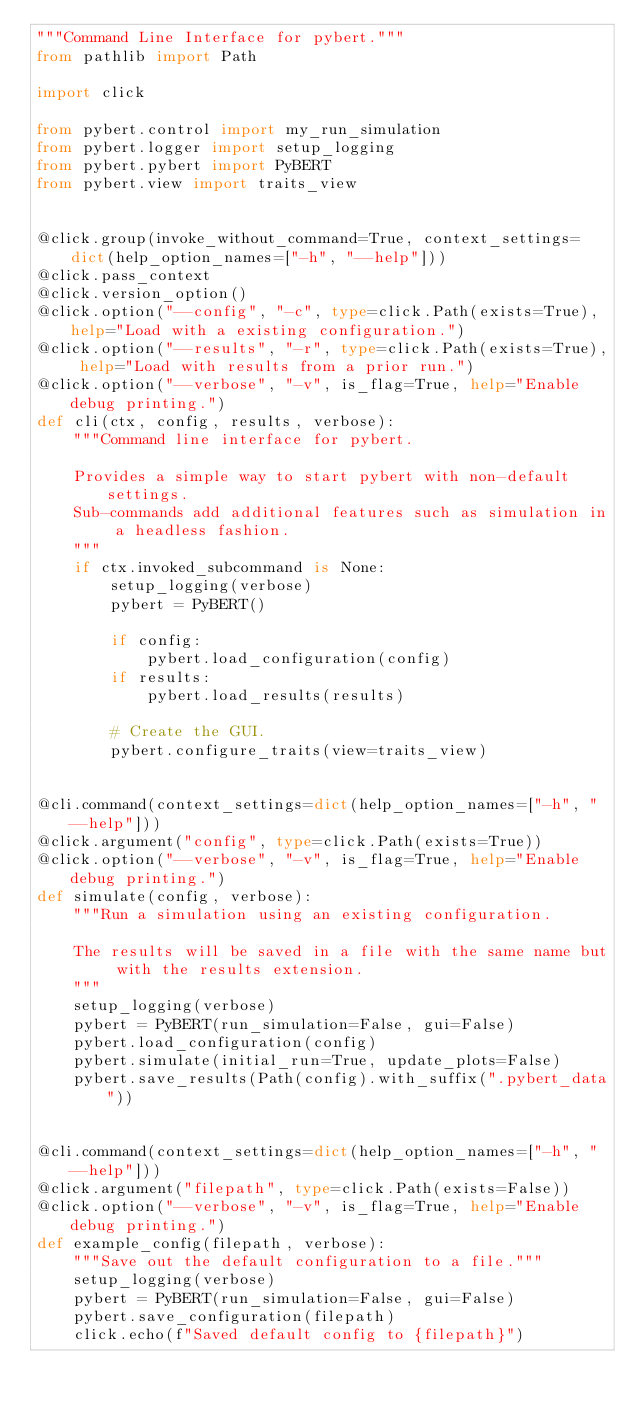Convert code to text. <code><loc_0><loc_0><loc_500><loc_500><_Python_>"""Command Line Interface for pybert."""
from pathlib import Path

import click

from pybert.control import my_run_simulation
from pybert.logger import setup_logging
from pybert.pybert import PyBERT
from pybert.view import traits_view


@click.group(invoke_without_command=True, context_settings=dict(help_option_names=["-h", "--help"]))
@click.pass_context
@click.version_option()
@click.option("--config", "-c", type=click.Path(exists=True), help="Load with a existing configuration.")
@click.option("--results", "-r", type=click.Path(exists=True), help="Load with results from a prior run.")
@click.option("--verbose", "-v", is_flag=True, help="Enable debug printing.")
def cli(ctx, config, results, verbose):
    """Command line interface for pybert.

    Provides a simple way to start pybert with non-default settings.
    Sub-commands add additional features such as simulation in a headless fashion.
    """
    if ctx.invoked_subcommand is None:
        setup_logging(verbose)
        pybert = PyBERT()

        if config:
            pybert.load_configuration(config)
        if results:
            pybert.load_results(results)

        # Create the GUI.
        pybert.configure_traits(view=traits_view)


@cli.command(context_settings=dict(help_option_names=["-h", "--help"]))
@click.argument("config", type=click.Path(exists=True))
@click.option("--verbose", "-v", is_flag=True, help="Enable debug printing.")
def simulate(config, verbose):
    """Run a simulation using an existing configuration.

    The results will be saved in a file with the same name but with the results extension.
    """
    setup_logging(verbose)
    pybert = PyBERT(run_simulation=False, gui=False)
    pybert.load_configuration(config)
    pybert.simulate(initial_run=True, update_plots=False)
    pybert.save_results(Path(config).with_suffix(".pybert_data"))


@cli.command(context_settings=dict(help_option_names=["-h", "--help"]))
@click.argument("filepath", type=click.Path(exists=False))
@click.option("--verbose", "-v", is_flag=True, help="Enable debug printing.")
def example_config(filepath, verbose):
    """Save out the default configuration to a file."""
    setup_logging(verbose)
    pybert = PyBERT(run_simulation=False, gui=False)
    pybert.save_configuration(filepath)
    click.echo(f"Saved default config to {filepath}")
</code> 